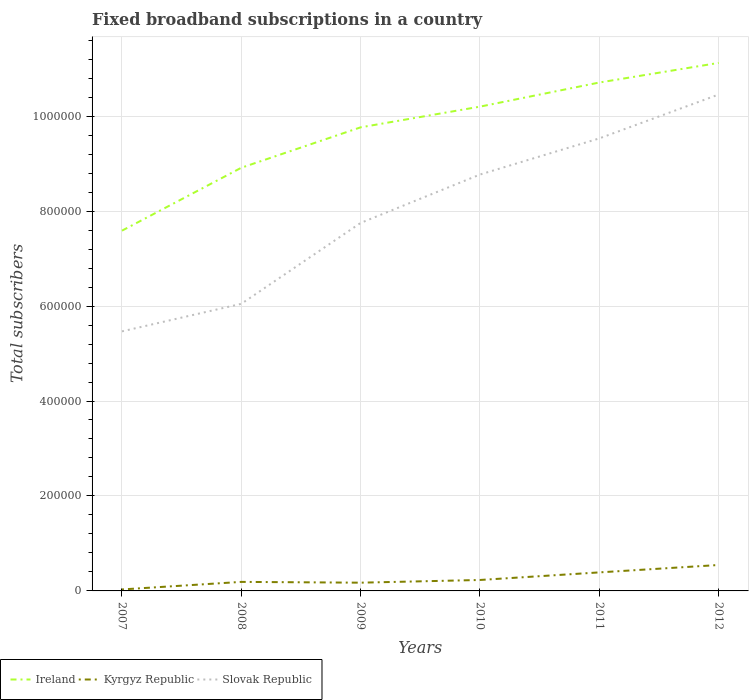Is the number of lines equal to the number of legend labels?
Your response must be concise. Yes. Across all years, what is the maximum number of broadband subscriptions in Slovak Republic?
Provide a succinct answer. 5.47e+05. What is the total number of broadband subscriptions in Kyrgyz Republic in the graph?
Ensure brevity in your answer.  -4021. What is the difference between the highest and the second highest number of broadband subscriptions in Kyrgyz Republic?
Offer a terse response. 5.15e+04. What is the difference between the highest and the lowest number of broadband subscriptions in Ireland?
Give a very brief answer. 4. Is the number of broadband subscriptions in Ireland strictly greater than the number of broadband subscriptions in Slovak Republic over the years?
Your response must be concise. No. How many years are there in the graph?
Give a very brief answer. 6. Are the values on the major ticks of Y-axis written in scientific E-notation?
Your response must be concise. No. Does the graph contain any zero values?
Your answer should be compact. No. Does the graph contain grids?
Offer a very short reply. Yes. How are the legend labels stacked?
Make the answer very short. Horizontal. What is the title of the graph?
Your answer should be very brief. Fixed broadband subscriptions in a country. Does "Cuba" appear as one of the legend labels in the graph?
Offer a very short reply. No. What is the label or title of the X-axis?
Offer a very short reply. Years. What is the label or title of the Y-axis?
Ensure brevity in your answer.  Total subscribers. What is the Total subscribers in Ireland in 2007?
Provide a succinct answer. 7.59e+05. What is the Total subscribers in Kyrgyz Republic in 2007?
Offer a terse response. 3115. What is the Total subscribers in Slovak Republic in 2007?
Keep it short and to the point. 5.47e+05. What is the Total subscribers in Ireland in 2008?
Provide a succinct answer. 8.91e+05. What is the Total subscribers of Kyrgyz Republic in 2008?
Offer a very short reply. 1.90e+04. What is the Total subscribers in Slovak Republic in 2008?
Your response must be concise. 6.05e+05. What is the Total subscribers of Ireland in 2009?
Provide a short and direct response. 9.76e+05. What is the Total subscribers of Kyrgyz Republic in 2009?
Make the answer very short. 1.74e+04. What is the Total subscribers of Slovak Republic in 2009?
Provide a short and direct response. 7.75e+05. What is the Total subscribers in Ireland in 2010?
Ensure brevity in your answer.  1.02e+06. What is the Total subscribers of Kyrgyz Republic in 2010?
Provide a succinct answer. 2.31e+04. What is the Total subscribers in Slovak Republic in 2010?
Ensure brevity in your answer.  8.77e+05. What is the Total subscribers in Ireland in 2011?
Make the answer very short. 1.07e+06. What is the Total subscribers in Kyrgyz Republic in 2011?
Offer a very short reply. 3.90e+04. What is the Total subscribers of Slovak Republic in 2011?
Offer a very short reply. 9.53e+05. What is the Total subscribers in Ireland in 2012?
Ensure brevity in your answer.  1.11e+06. What is the Total subscribers in Kyrgyz Republic in 2012?
Give a very brief answer. 5.46e+04. What is the Total subscribers of Slovak Republic in 2012?
Provide a succinct answer. 1.05e+06. Across all years, what is the maximum Total subscribers in Ireland?
Provide a succinct answer. 1.11e+06. Across all years, what is the maximum Total subscribers of Kyrgyz Republic?
Offer a very short reply. 5.46e+04. Across all years, what is the maximum Total subscribers of Slovak Republic?
Offer a terse response. 1.05e+06. Across all years, what is the minimum Total subscribers of Ireland?
Offer a very short reply. 7.59e+05. Across all years, what is the minimum Total subscribers of Kyrgyz Republic?
Your answer should be compact. 3115. Across all years, what is the minimum Total subscribers of Slovak Republic?
Keep it short and to the point. 5.47e+05. What is the total Total subscribers in Ireland in the graph?
Give a very brief answer. 5.83e+06. What is the total Total subscribers of Kyrgyz Republic in the graph?
Provide a succinct answer. 1.56e+05. What is the total Total subscribers in Slovak Republic in the graph?
Provide a succinct answer. 4.80e+06. What is the difference between the Total subscribers in Ireland in 2007 and that in 2008?
Your answer should be compact. -1.33e+05. What is the difference between the Total subscribers of Kyrgyz Republic in 2007 and that in 2008?
Your answer should be very brief. -1.59e+04. What is the difference between the Total subscribers of Slovak Republic in 2007 and that in 2008?
Your answer should be compact. -5.80e+04. What is the difference between the Total subscribers in Ireland in 2007 and that in 2009?
Your answer should be very brief. -2.18e+05. What is the difference between the Total subscribers in Kyrgyz Republic in 2007 and that in 2009?
Provide a succinct answer. -1.42e+04. What is the difference between the Total subscribers in Slovak Republic in 2007 and that in 2009?
Provide a short and direct response. -2.28e+05. What is the difference between the Total subscribers of Ireland in 2007 and that in 2010?
Offer a very short reply. -2.61e+05. What is the difference between the Total subscribers in Kyrgyz Republic in 2007 and that in 2010?
Keep it short and to the point. -1.99e+04. What is the difference between the Total subscribers in Slovak Republic in 2007 and that in 2010?
Make the answer very short. -3.30e+05. What is the difference between the Total subscribers of Ireland in 2007 and that in 2011?
Provide a succinct answer. -3.12e+05. What is the difference between the Total subscribers in Kyrgyz Republic in 2007 and that in 2011?
Offer a very short reply. -3.59e+04. What is the difference between the Total subscribers of Slovak Republic in 2007 and that in 2011?
Provide a succinct answer. -4.06e+05. What is the difference between the Total subscribers in Ireland in 2007 and that in 2012?
Offer a very short reply. -3.53e+05. What is the difference between the Total subscribers in Kyrgyz Republic in 2007 and that in 2012?
Provide a short and direct response. -5.15e+04. What is the difference between the Total subscribers in Slovak Republic in 2007 and that in 2012?
Provide a short and direct response. -4.99e+05. What is the difference between the Total subscribers in Ireland in 2008 and that in 2009?
Keep it short and to the point. -8.51e+04. What is the difference between the Total subscribers in Kyrgyz Republic in 2008 and that in 2009?
Give a very brief answer. 1677. What is the difference between the Total subscribers in Slovak Republic in 2008 and that in 2009?
Your answer should be very brief. -1.70e+05. What is the difference between the Total subscribers in Ireland in 2008 and that in 2010?
Keep it short and to the point. -1.29e+05. What is the difference between the Total subscribers in Kyrgyz Republic in 2008 and that in 2010?
Provide a succinct answer. -4021. What is the difference between the Total subscribers in Slovak Republic in 2008 and that in 2010?
Keep it short and to the point. -2.72e+05. What is the difference between the Total subscribers of Ireland in 2008 and that in 2011?
Offer a terse response. -1.80e+05. What is the difference between the Total subscribers of Kyrgyz Republic in 2008 and that in 2011?
Offer a very short reply. -2.00e+04. What is the difference between the Total subscribers in Slovak Republic in 2008 and that in 2011?
Your response must be concise. -3.48e+05. What is the difference between the Total subscribers of Ireland in 2008 and that in 2012?
Provide a short and direct response. -2.21e+05. What is the difference between the Total subscribers of Kyrgyz Republic in 2008 and that in 2012?
Provide a succinct answer. -3.56e+04. What is the difference between the Total subscribers in Slovak Republic in 2008 and that in 2012?
Give a very brief answer. -4.41e+05. What is the difference between the Total subscribers of Ireland in 2009 and that in 2010?
Ensure brevity in your answer.  -4.36e+04. What is the difference between the Total subscribers of Kyrgyz Republic in 2009 and that in 2010?
Your response must be concise. -5698. What is the difference between the Total subscribers in Slovak Republic in 2009 and that in 2010?
Make the answer very short. -1.02e+05. What is the difference between the Total subscribers in Ireland in 2009 and that in 2011?
Your answer should be compact. -9.44e+04. What is the difference between the Total subscribers in Kyrgyz Republic in 2009 and that in 2011?
Give a very brief answer. -2.17e+04. What is the difference between the Total subscribers in Slovak Republic in 2009 and that in 2011?
Ensure brevity in your answer.  -1.78e+05. What is the difference between the Total subscribers in Ireland in 2009 and that in 2012?
Provide a short and direct response. -1.36e+05. What is the difference between the Total subscribers in Kyrgyz Republic in 2009 and that in 2012?
Your answer should be very brief. -3.73e+04. What is the difference between the Total subscribers in Slovak Republic in 2009 and that in 2012?
Keep it short and to the point. -2.70e+05. What is the difference between the Total subscribers in Ireland in 2010 and that in 2011?
Offer a very short reply. -5.08e+04. What is the difference between the Total subscribers of Kyrgyz Republic in 2010 and that in 2011?
Keep it short and to the point. -1.60e+04. What is the difference between the Total subscribers in Slovak Republic in 2010 and that in 2011?
Offer a very short reply. -7.61e+04. What is the difference between the Total subscribers in Ireland in 2010 and that in 2012?
Offer a terse response. -9.21e+04. What is the difference between the Total subscribers of Kyrgyz Republic in 2010 and that in 2012?
Make the answer very short. -3.16e+04. What is the difference between the Total subscribers in Slovak Republic in 2010 and that in 2012?
Provide a succinct answer. -1.69e+05. What is the difference between the Total subscribers of Ireland in 2011 and that in 2012?
Make the answer very short. -4.13e+04. What is the difference between the Total subscribers of Kyrgyz Republic in 2011 and that in 2012?
Give a very brief answer. -1.56e+04. What is the difference between the Total subscribers in Slovak Republic in 2011 and that in 2012?
Give a very brief answer. -9.24e+04. What is the difference between the Total subscribers of Ireland in 2007 and the Total subscribers of Kyrgyz Republic in 2008?
Offer a very short reply. 7.40e+05. What is the difference between the Total subscribers of Ireland in 2007 and the Total subscribers of Slovak Republic in 2008?
Your answer should be compact. 1.54e+05. What is the difference between the Total subscribers of Kyrgyz Republic in 2007 and the Total subscribers of Slovak Republic in 2008?
Keep it short and to the point. -6.02e+05. What is the difference between the Total subscribers of Ireland in 2007 and the Total subscribers of Kyrgyz Republic in 2009?
Make the answer very short. 7.41e+05. What is the difference between the Total subscribers in Ireland in 2007 and the Total subscribers in Slovak Republic in 2009?
Make the answer very short. -1.63e+04. What is the difference between the Total subscribers in Kyrgyz Republic in 2007 and the Total subscribers in Slovak Republic in 2009?
Provide a short and direct response. -7.72e+05. What is the difference between the Total subscribers of Ireland in 2007 and the Total subscribers of Kyrgyz Republic in 2010?
Your answer should be very brief. 7.36e+05. What is the difference between the Total subscribers of Ireland in 2007 and the Total subscribers of Slovak Republic in 2010?
Give a very brief answer. -1.18e+05. What is the difference between the Total subscribers in Kyrgyz Republic in 2007 and the Total subscribers in Slovak Republic in 2010?
Your answer should be very brief. -8.74e+05. What is the difference between the Total subscribers of Ireland in 2007 and the Total subscribers of Kyrgyz Republic in 2011?
Provide a short and direct response. 7.20e+05. What is the difference between the Total subscribers in Ireland in 2007 and the Total subscribers in Slovak Republic in 2011?
Provide a short and direct response. -1.94e+05. What is the difference between the Total subscribers of Kyrgyz Republic in 2007 and the Total subscribers of Slovak Republic in 2011?
Make the answer very short. -9.50e+05. What is the difference between the Total subscribers in Ireland in 2007 and the Total subscribers in Kyrgyz Republic in 2012?
Provide a short and direct response. 7.04e+05. What is the difference between the Total subscribers of Ireland in 2007 and the Total subscribers of Slovak Republic in 2012?
Provide a succinct answer. -2.87e+05. What is the difference between the Total subscribers in Kyrgyz Republic in 2007 and the Total subscribers in Slovak Republic in 2012?
Ensure brevity in your answer.  -1.04e+06. What is the difference between the Total subscribers of Ireland in 2008 and the Total subscribers of Kyrgyz Republic in 2009?
Give a very brief answer. 8.74e+05. What is the difference between the Total subscribers of Ireland in 2008 and the Total subscribers of Slovak Republic in 2009?
Your answer should be very brief. 1.16e+05. What is the difference between the Total subscribers of Kyrgyz Republic in 2008 and the Total subscribers of Slovak Republic in 2009?
Keep it short and to the point. -7.56e+05. What is the difference between the Total subscribers in Ireland in 2008 and the Total subscribers in Kyrgyz Republic in 2010?
Provide a short and direct response. 8.68e+05. What is the difference between the Total subscribers of Ireland in 2008 and the Total subscribers of Slovak Republic in 2010?
Keep it short and to the point. 1.43e+04. What is the difference between the Total subscribers in Kyrgyz Republic in 2008 and the Total subscribers in Slovak Republic in 2010?
Your answer should be very brief. -8.58e+05. What is the difference between the Total subscribers in Ireland in 2008 and the Total subscribers in Kyrgyz Republic in 2011?
Your response must be concise. 8.52e+05. What is the difference between the Total subscribers of Ireland in 2008 and the Total subscribers of Slovak Republic in 2011?
Give a very brief answer. -6.19e+04. What is the difference between the Total subscribers of Kyrgyz Republic in 2008 and the Total subscribers of Slovak Republic in 2011?
Offer a very short reply. -9.34e+05. What is the difference between the Total subscribers in Ireland in 2008 and the Total subscribers in Kyrgyz Republic in 2012?
Make the answer very short. 8.37e+05. What is the difference between the Total subscribers in Ireland in 2008 and the Total subscribers in Slovak Republic in 2012?
Give a very brief answer. -1.54e+05. What is the difference between the Total subscribers in Kyrgyz Republic in 2008 and the Total subscribers in Slovak Republic in 2012?
Keep it short and to the point. -1.03e+06. What is the difference between the Total subscribers of Ireland in 2009 and the Total subscribers of Kyrgyz Republic in 2010?
Your response must be concise. 9.53e+05. What is the difference between the Total subscribers in Ireland in 2009 and the Total subscribers in Slovak Republic in 2010?
Your answer should be very brief. 9.94e+04. What is the difference between the Total subscribers of Kyrgyz Republic in 2009 and the Total subscribers of Slovak Republic in 2010?
Your answer should be very brief. -8.60e+05. What is the difference between the Total subscribers in Ireland in 2009 and the Total subscribers in Kyrgyz Republic in 2011?
Keep it short and to the point. 9.37e+05. What is the difference between the Total subscribers of Ireland in 2009 and the Total subscribers of Slovak Republic in 2011?
Give a very brief answer. 2.33e+04. What is the difference between the Total subscribers of Kyrgyz Republic in 2009 and the Total subscribers of Slovak Republic in 2011?
Ensure brevity in your answer.  -9.36e+05. What is the difference between the Total subscribers in Ireland in 2009 and the Total subscribers in Kyrgyz Republic in 2012?
Ensure brevity in your answer.  9.22e+05. What is the difference between the Total subscribers of Ireland in 2009 and the Total subscribers of Slovak Republic in 2012?
Make the answer very short. -6.91e+04. What is the difference between the Total subscribers of Kyrgyz Republic in 2009 and the Total subscribers of Slovak Republic in 2012?
Give a very brief answer. -1.03e+06. What is the difference between the Total subscribers in Ireland in 2010 and the Total subscribers in Kyrgyz Republic in 2011?
Offer a terse response. 9.81e+05. What is the difference between the Total subscribers in Ireland in 2010 and the Total subscribers in Slovak Republic in 2011?
Ensure brevity in your answer.  6.69e+04. What is the difference between the Total subscribers in Kyrgyz Republic in 2010 and the Total subscribers in Slovak Republic in 2011?
Make the answer very short. -9.30e+05. What is the difference between the Total subscribers in Ireland in 2010 and the Total subscribers in Kyrgyz Republic in 2012?
Offer a terse response. 9.65e+05. What is the difference between the Total subscribers of Ireland in 2010 and the Total subscribers of Slovak Republic in 2012?
Offer a very short reply. -2.55e+04. What is the difference between the Total subscribers of Kyrgyz Republic in 2010 and the Total subscribers of Slovak Republic in 2012?
Make the answer very short. -1.02e+06. What is the difference between the Total subscribers in Ireland in 2011 and the Total subscribers in Kyrgyz Republic in 2012?
Your answer should be compact. 1.02e+06. What is the difference between the Total subscribers of Ireland in 2011 and the Total subscribers of Slovak Republic in 2012?
Offer a terse response. 2.53e+04. What is the difference between the Total subscribers in Kyrgyz Republic in 2011 and the Total subscribers in Slovak Republic in 2012?
Offer a terse response. -1.01e+06. What is the average Total subscribers of Ireland per year?
Offer a very short reply. 9.72e+05. What is the average Total subscribers in Kyrgyz Republic per year?
Your response must be concise. 2.60e+04. What is the average Total subscribers in Slovak Republic per year?
Your response must be concise. 8.00e+05. In the year 2007, what is the difference between the Total subscribers in Ireland and Total subscribers in Kyrgyz Republic?
Ensure brevity in your answer.  7.56e+05. In the year 2007, what is the difference between the Total subscribers of Ireland and Total subscribers of Slovak Republic?
Ensure brevity in your answer.  2.12e+05. In the year 2007, what is the difference between the Total subscribers of Kyrgyz Republic and Total subscribers of Slovak Republic?
Your answer should be very brief. -5.44e+05. In the year 2008, what is the difference between the Total subscribers of Ireland and Total subscribers of Kyrgyz Republic?
Make the answer very short. 8.72e+05. In the year 2008, what is the difference between the Total subscribers in Ireland and Total subscribers in Slovak Republic?
Offer a very short reply. 2.87e+05. In the year 2008, what is the difference between the Total subscribers in Kyrgyz Republic and Total subscribers in Slovak Republic?
Ensure brevity in your answer.  -5.86e+05. In the year 2009, what is the difference between the Total subscribers in Ireland and Total subscribers in Kyrgyz Republic?
Make the answer very short. 9.59e+05. In the year 2009, what is the difference between the Total subscribers of Ireland and Total subscribers of Slovak Republic?
Provide a succinct answer. 2.01e+05. In the year 2009, what is the difference between the Total subscribers of Kyrgyz Republic and Total subscribers of Slovak Republic?
Offer a very short reply. -7.58e+05. In the year 2010, what is the difference between the Total subscribers in Ireland and Total subscribers in Kyrgyz Republic?
Make the answer very short. 9.97e+05. In the year 2010, what is the difference between the Total subscribers of Ireland and Total subscribers of Slovak Republic?
Provide a succinct answer. 1.43e+05. In the year 2010, what is the difference between the Total subscribers of Kyrgyz Republic and Total subscribers of Slovak Republic?
Offer a very short reply. -8.54e+05. In the year 2011, what is the difference between the Total subscribers of Ireland and Total subscribers of Kyrgyz Republic?
Your answer should be very brief. 1.03e+06. In the year 2011, what is the difference between the Total subscribers in Ireland and Total subscribers in Slovak Republic?
Offer a very short reply. 1.18e+05. In the year 2011, what is the difference between the Total subscribers in Kyrgyz Republic and Total subscribers in Slovak Republic?
Provide a short and direct response. -9.14e+05. In the year 2012, what is the difference between the Total subscribers in Ireland and Total subscribers in Kyrgyz Republic?
Your answer should be compact. 1.06e+06. In the year 2012, what is the difference between the Total subscribers of Ireland and Total subscribers of Slovak Republic?
Give a very brief answer. 6.66e+04. In the year 2012, what is the difference between the Total subscribers of Kyrgyz Republic and Total subscribers of Slovak Republic?
Make the answer very short. -9.91e+05. What is the ratio of the Total subscribers of Ireland in 2007 to that in 2008?
Your answer should be compact. 0.85. What is the ratio of the Total subscribers of Kyrgyz Republic in 2007 to that in 2008?
Make the answer very short. 0.16. What is the ratio of the Total subscribers of Slovak Republic in 2007 to that in 2008?
Your answer should be very brief. 0.9. What is the ratio of the Total subscribers in Ireland in 2007 to that in 2009?
Provide a succinct answer. 0.78. What is the ratio of the Total subscribers in Kyrgyz Republic in 2007 to that in 2009?
Give a very brief answer. 0.18. What is the ratio of the Total subscribers of Slovak Republic in 2007 to that in 2009?
Offer a very short reply. 0.71. What is the ratio of the Total subscribers of Ireland in 2007 to that in 2010?
Your answer should be very brief. 0.74. What is the ratio of the Total subscribers in Kyrgyz Republic in 2007 to that in 2010?
Give a very brief answer. 0.14. What is the ratio of the Total subscribers of Slovak Republic in 2007 to that in 2010?
Make the answer very short. 0.62. What is the ratio of the Total subscribers of Ireland in 2007 to that in 2011?
Keep it short and to the point. 0.71. What is the ratio of the Total subscribers of Kyrgyz Republic in 2007 to that in 2011?
Offer a very short reply. 0.08. What is the ratio of the Total subscribers of Slovak Republic in 2007 to that in 2011?
Offer a very short reply. 0.57. What is the ratio of the Total subscribers in Ireland in 2007 to that in 2012?
Keep it short and to the point. 0.68. What is the ratio of the Total subscribers in Kyrgyz Republic in 2007 to that in 2012?
Give a very brief answer. 0.06. What is the ratio of the Total subscribers in Slovak Republic in 2007 to that in 2012?
Your answer should be compact. 0.52. What is the ratio of the Total subscribers in Ireland in 2008 to that in 2009?
Make the answer very short. 0.91. What is the ratio of the Total subscribers in Kyrgyz Republic in 2008 to that in 2009?
Your answer should be compact. 1.1. What is the ratio of the Total subscribers of Slovak Republic in 2008 to that in 2009?
Offer a very short reply. 0.78. What is the ratio of the Total subscribers of Ireland in 2008 to that in 2010?
Provide a succinct answer. 0.87. What is the ratio of the Total subscribers of Kyrgyz Republic in 2008 to that in 2010?
Ensure brevity in your answer.  0.83. What is the ratio of the Total subscribers in Slovak Republic in 2008 to that in 2010?
Give a very brief answer. 0.69. What is the ratio of the Total subscribers of Ireland in 2008 to that in 2011?
Provide a short and direct response. 0.83. What is the ratio of the Total subscribers in Kyrgyz Republic in 2008 to that in 2011?
Offer a very short reply. 0.49. What is the ratio of the Total subscribers in Slovak Republic in 2008 to that in 2011?
Ensure brevity in your answer.  0.63. What is the ratio of the Total subscribers of Ireland in 2008 to that in 2012?
Your answer should be very brief. 0.8. What is the ratio of the Total subscribers of Kyrgyz Republic in 2008 to that in 2012?
Make the answer very short. 0.35. What is the ratio of the Total subscribers of Slovak Republic in 2008 to that in 2012?
Your response must be concise. 0.58. What is the ratio of the Total subscribers of Ireland in 2009 to that in 2010?
Provide a short and direct response. 0.96. What is the ratio of the Total subscribers of Kyrgyz Republic in 2009 to that in 2010?
Offer a terse response. 0.75. What is the ratio of the Total subscribers in Slovak Republic in 2009 to that in 2010?
Make the answer very short. 0.88. What is the ratio of the Total subscribers of Ireland in 2009 to that in 2011?
Keep it short and to the point. 0.91. What is the ratio of the Total subscribers of Kyrgyz Republic in 2009 to that in 2011?
Your answer should be very brief. 0.44. What is the ratio of the Total subscribers in Slovak Republic in 2009 to that in 2011?
Provide a short and direct response. 0.81. What is the ratio of the Total subscribers of Ireland in 2009 to that in 2012?
Make the answer very short. 0.88. What is the ratio of the Total subscribers of Kyrgyz Republic in 2009 to that in 2012?
Your answer should be very brief. 0.32. What is the ratio of the Total subscribers of Slovak Republic in 2009 to that in 2012?
Offer a very short reply. 0.74. What is the ratio of the Total subscribers of Ireland in 2010 to that in 2011?
Make the answer very short. 0.95. What is the ratio of the Total subscribers in Kyrgyz Republic in 2010 to that in 2011?
Offer a terse response. 0.59. What is the ratio of the Total subscribers in Slovak Republic in 2010 to that in 2011?
Provide a succinct answer. 0.92. What is the ratio of the Total subscribers of Ireland in 2010 to that in 2012?
Your answer should be very brief. 0.92. What is the ratio of the Total subscribers in Kyrgyz Republic in 2010 to that in 2012?
Make the answer very short. 0.42. What is the ratio of the Total subscribers in Slovak Republic in 2010 to that in 2012?
Your answer should be very brief. 0.84. What is the ratio of the Total subscribers in Ireland in 2011 to that in 2012?
Offer a terse response. 0.96. What is the ratio of the Total subscribers in Kyrgyz Republic in 2011 to that in 2012?
Offer a very short reply. 0.71. What is the ratio of the Total subscribers in Slovak Republic in 2011 to that in 2012?
Give a very brief answer. 0.91. What is the difference between the highest and the second highest Total subscribers in Ireland?
Your answer should be very brief. 4.13e+04. What is the difference between the highest and the second highest Total subscribers of Kyrgyz Republic?
Keep it short and to the point. 1.56e+04. What is the difference between the highest and the second highest Total subscribers in Slovak Republic?
Your response must be concise. 9.24e+04. What is the difference between the highest and the lowest Total subscribers in Ireland?
Give a very brief answer. 3.53e+05. What is the difference between the highest and the lowest Total subscribers of Kyrgyz Republic?
Your answer should be very brief. 5.15e+04. What is the difference between the highest and the lowest Total subscribers of Slovak Republic?
Offer a very short reply. 4.99e+05. 